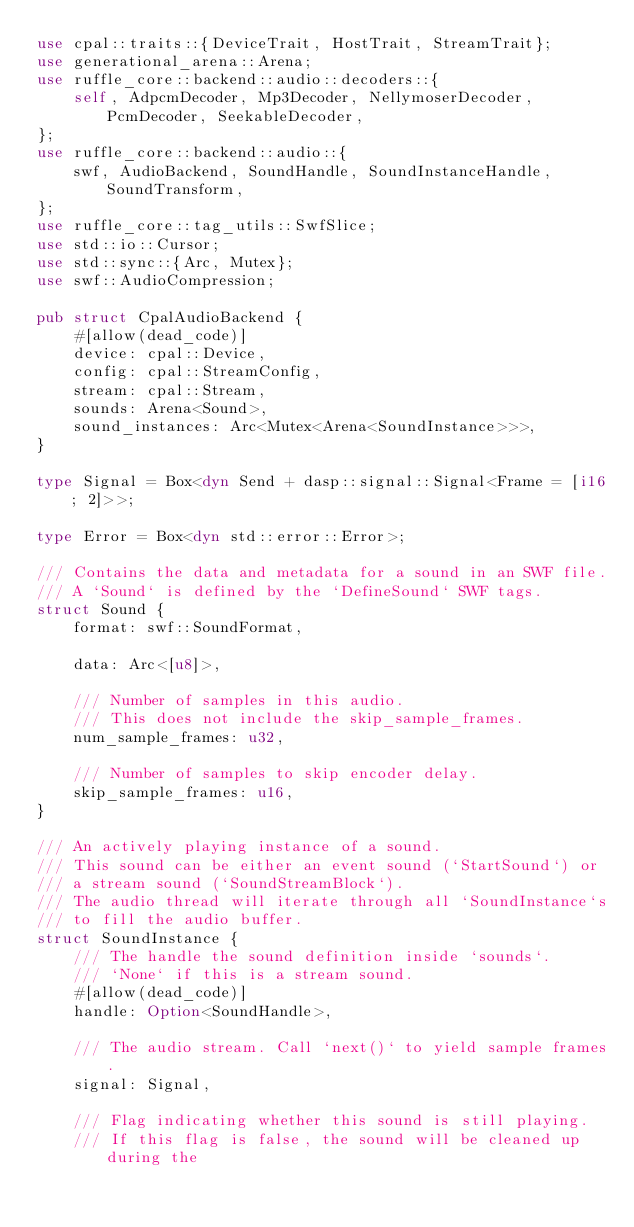<code> <loc_0><loc_0><loc_500><loc_500><_Rust_>use cpal::traits::{DeviceTrait, HostTrait, StreamTrait};
use generational_arena::Arena;
use ruffle_core::backend::audio::decoders::{
    self, AdpcmDecoder, Mp3Decoder, NellymoserDecoder, PcmDecoder, SeekableDecoder,
};
use ruffle_core::backend::audio::{
    swf, AudioBackend, SoundHandle, SoundInstanceHandle, SoundTransform,
};
use ruffle_core::tag_utils::SwfSlice;
use std::io::Cursor;
use std::sync::{Arc, Mutex};
use swf::AudioCompression;

pub struct CpalAudioBackend {
    #[allow(dead_code)]
    device: cpal::Device,
    config: cpal::StreamConfig,
    stream: cpal::Stream,
    sounds: Arena<Sound>,
    sound_instances: Arc<Mutex<Arena<SoundInstance>>>,
}

type Signal = Box<dyn Send + dasp::signal::Signal<Frame = [i16; 2]>>;

type Error = Box<dyn std::error::Error>;

/// Contains the data and metadata for a sound in an SWF file.
/// A `Sound` is defined by the `DefineSound` SWF tags.
struct Sound {
    format: swf::SoundFormat,

    data: Arc<[u8]>,

    /// Number of samples in this audio.
    /// This does not include the skip_sample_frames.
    num_sample_frames: u32,

    /// Number of samples to skip encoder delay.
    skip_sample_frames: u16,
}

/// An actively playing instance of a sound.
/// This sound can be either an event sound (`StartSound`) or
/// a stream sound (`SoundStreamBlock`).
/// The audio thread will iterate through all `SoundInstance`s
/// to fill the audio buffer.
struct SoundInstance {
    /// The handle the sound definition inside `sounds`.
    /// `None` if this is a stream sound.
    #[allow(dead_code)]
    handle: Option<SoundHandle>,

    /// The audio stream. Call `next()` to yield sample frames.
    signal: Signal,

    /// Flag indicating whether this sound is still playing.
    /// If this flag is false, the sound will be cleaned up during the</code> 